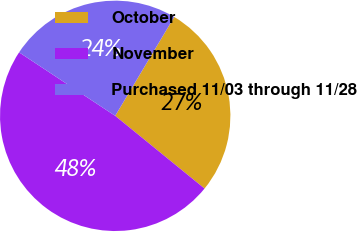<chart> <loc_0><loc_0><loc_500><loc_500><pie_chart><fcel>October<fcel>November<fcel>Purchased 11/03 through 11/28<nl><fcel>27.31%<fcel>48.42%<fcel>24.27%<nl></chart> 